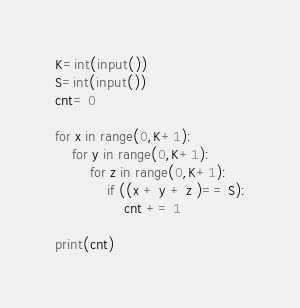Convert code to text. <code><loc_0><loc_0><loc_500><loc_500><_Python_>K=int(input())
S=int(input())
cnt= 0

for x in range(0,K+1):
    for y in range(0,K+1):
        for z in range(0,K+1):
            if ((x + y + z )== S):
                cnt += 1

print(cnt)</code> 